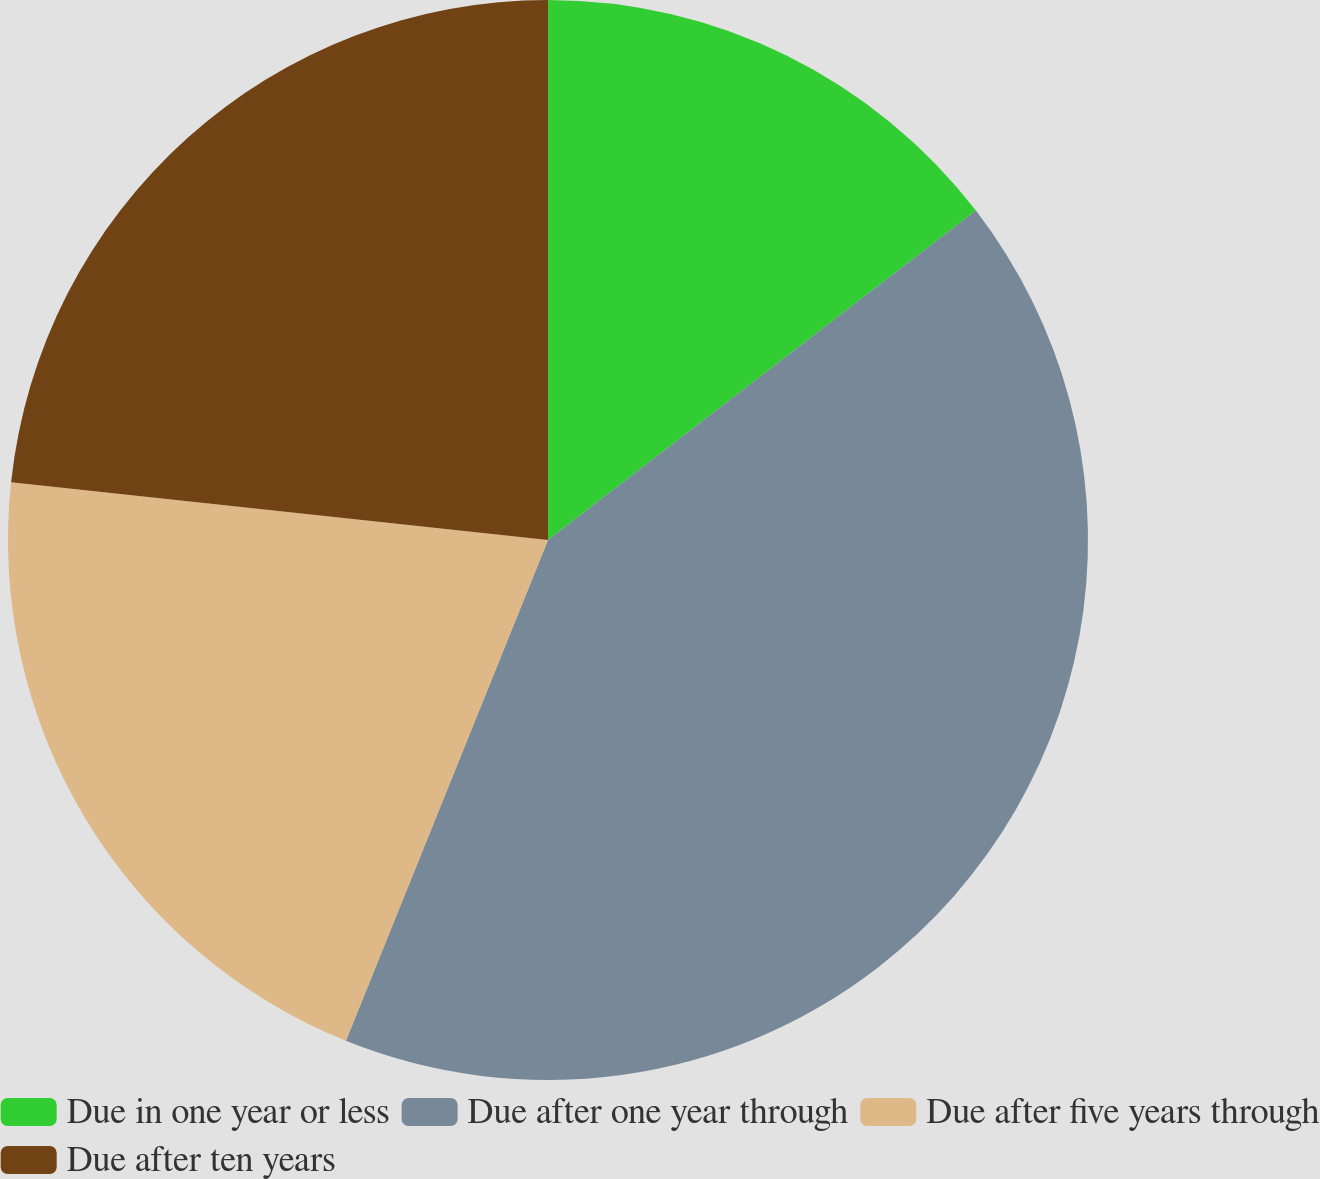Convert chart. <chart><loc_0><loc_0><loc_500><loc_500><pie_chart><fcel>Due in one year or less<fcel>Due after one year through<fcel>Due after five years through<fcel>Due after ten years<nl><fcel>14.56%<fcel>41.55%<fcel>20.6%<fcel>23.3%<nl></chart> 